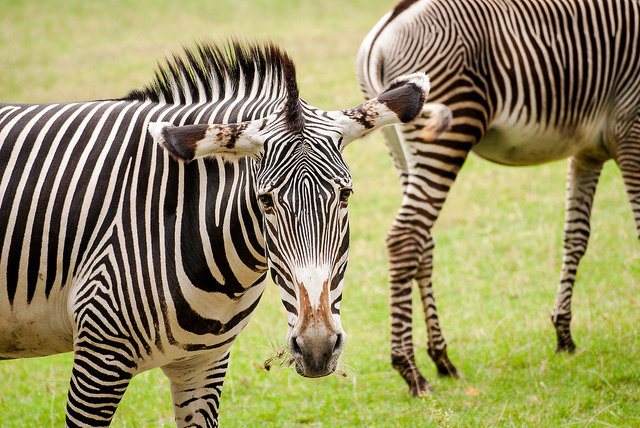Can you elaborate on the elements of the picture provided? Two zebras are captured in the image. The zebra on the left covers a significant portion of the image and extends vertically almost from top to bottom. Meanwhile, the zebra on the right occupies the space from the top edge to almost the bottom right corner, showcasing its side profile. 